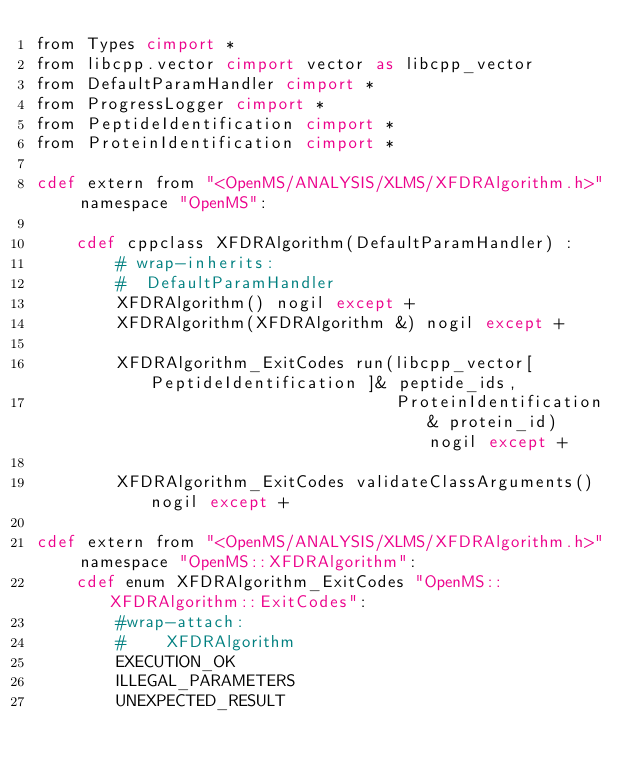Convert code to text. <code><loc_0><loc_0><loc_500><loc_500><_Cython_>from Types cimport *
from libcpp.vector cimport vector as libcpp_vector
from DefaultParamHandler cimport *
from ProgressLogger cimport *
from PeptideIdentification cimport *
from ProteinIdentification cimport *

cdef extern from "<OpenMS/ANALYSIS/XLMS/XFDRAlgorithm.h>" namespace "OpenMS":

    cdef cppclass XFDRAlgorithm(DefaultParamHandler) :
        # wrap-inherits:
        #  DefaultParamHandler
        XFDRAlgorithm() nogil except +
        XFDRAlgorithm(XFDRAlgorithm &) nogil except +

        XFDRAlgorithm_ExitCodes run(libcpp_vector[ PeptideIdentification ]& peptide_ids,
                                    ProteinIdentification& protein_id) nogil except +

        XFDRAlgorithm_ExitCodes validateClassArguments() nogil except +

cdef extern from "<OpenMS/ANALYSIS/XLMS/XFDRAlgorithm.h>" namespace "OpenMS::XFDRAlgorithm":
    cdef enum XFDRAlgorithm_ExitCodes "OpenMS::XFDRAlgorithm::ExitCodes":
        #wrap-attach:
        #    XFDRAlgorithm
        EXECUTION_OK
        ILLEGAL_PARAMETERS
        UNEXPECTED_RESULT
</code> 